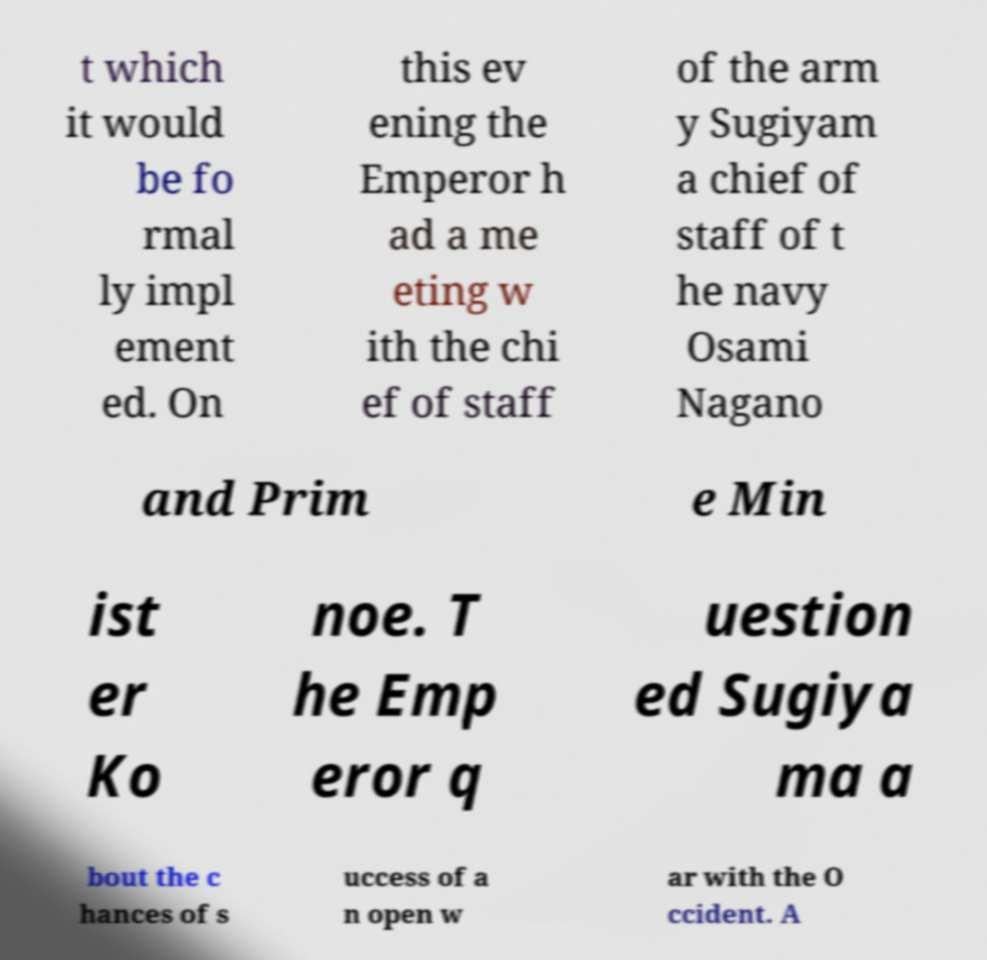I need the written content from this picture converted into text. Can you do that? t which it would be fo rmal ly impl ement ed. On this ev ening the Emperor h ad a me eting w ith the chi ef of staff of the arm y Sugiyam a chief of staff of t he navy Osami Nagano and Prim e Min ist er Ko noe. T he Emp eror q uestion ed Sugiya ma a bout the c hances of s uccess of a n open w ar with the O ccident. A 